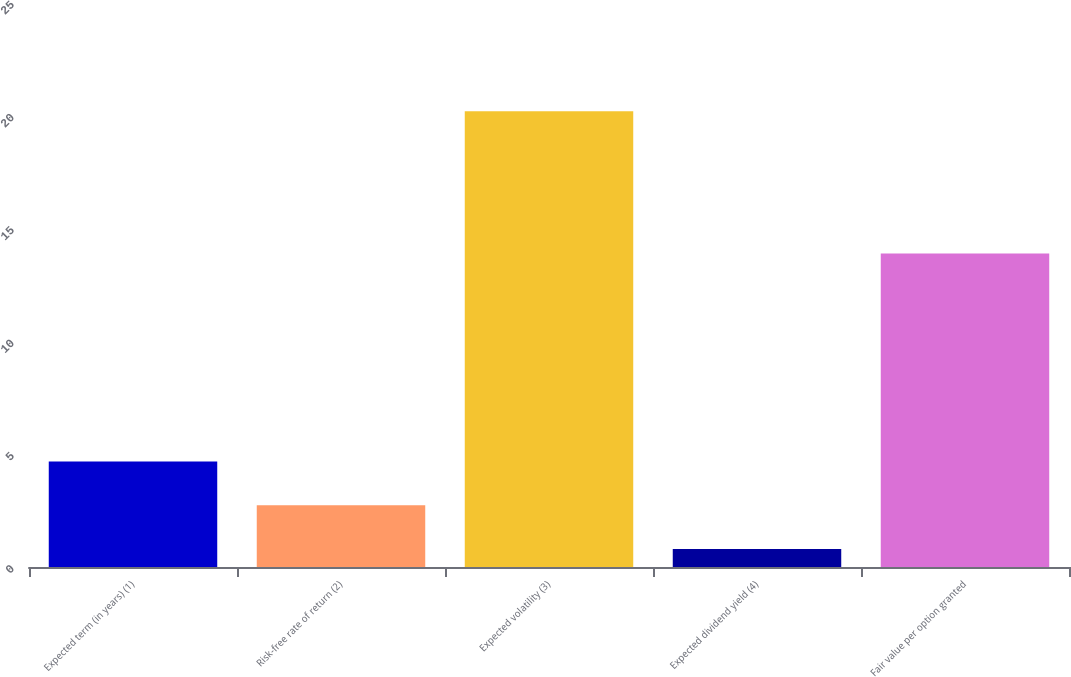Convert chart. <chart><loc_0><loc_0><loc_500><loc_500><bar_chart><fcel>Expected term (in years) (1)<fcel>Risk-free rate of return (2)<fcel>Expected volatility (3)<fcel>Expected dividend yield (4)<fcel>Fair value per option granted<nl><fcel>4.68<fcel>2.74<fcel>20.2<fcel>0.8<fcel>13.9<nl></chart> 